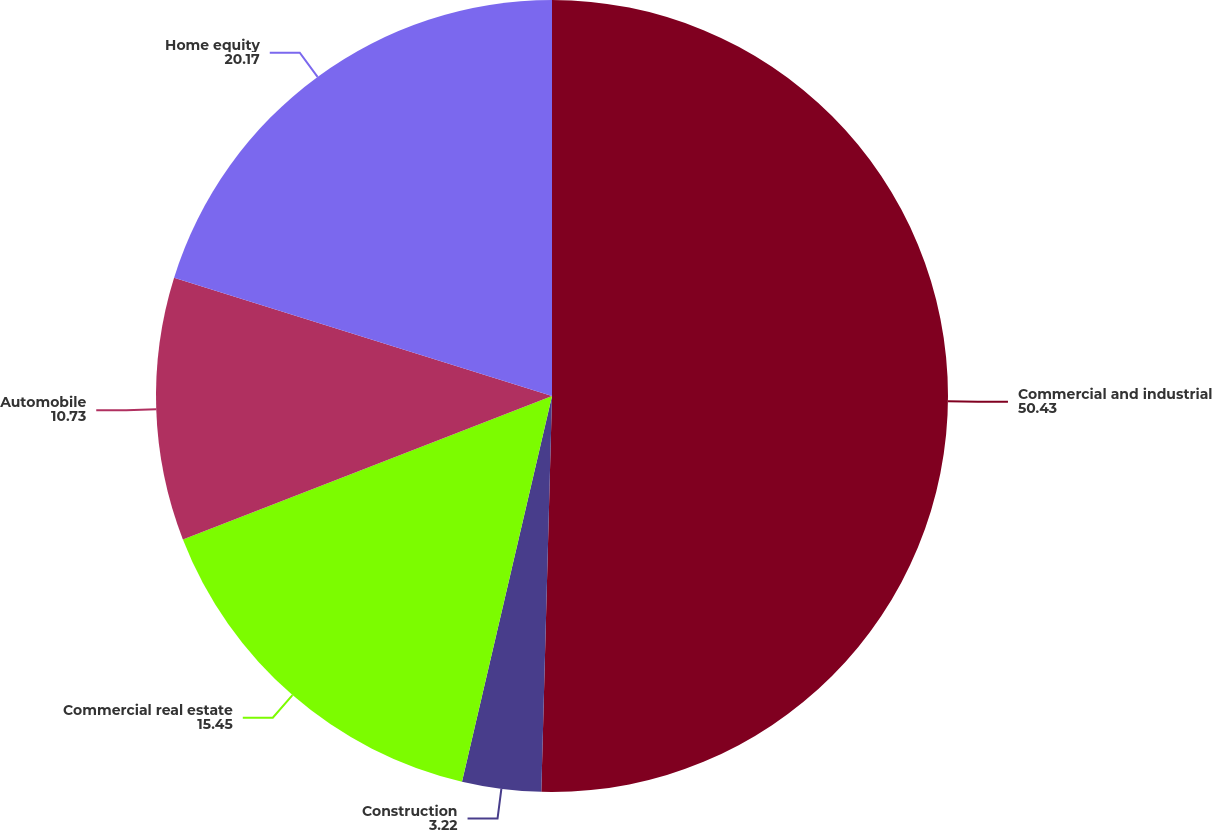Convert chart. <chart><loc_0><loc_0><loc_500><loc_500><pie_chart><fcel>Commercial and industrial<fcel>Construction<fcel>Commercial real estate<fcel>Automobile<fcel>Home equity<nl><fcel>50.43%<fcel>3.22%<fcel>15.45%<fcel>10.73%<fcel>20.17%<nl></chart> 